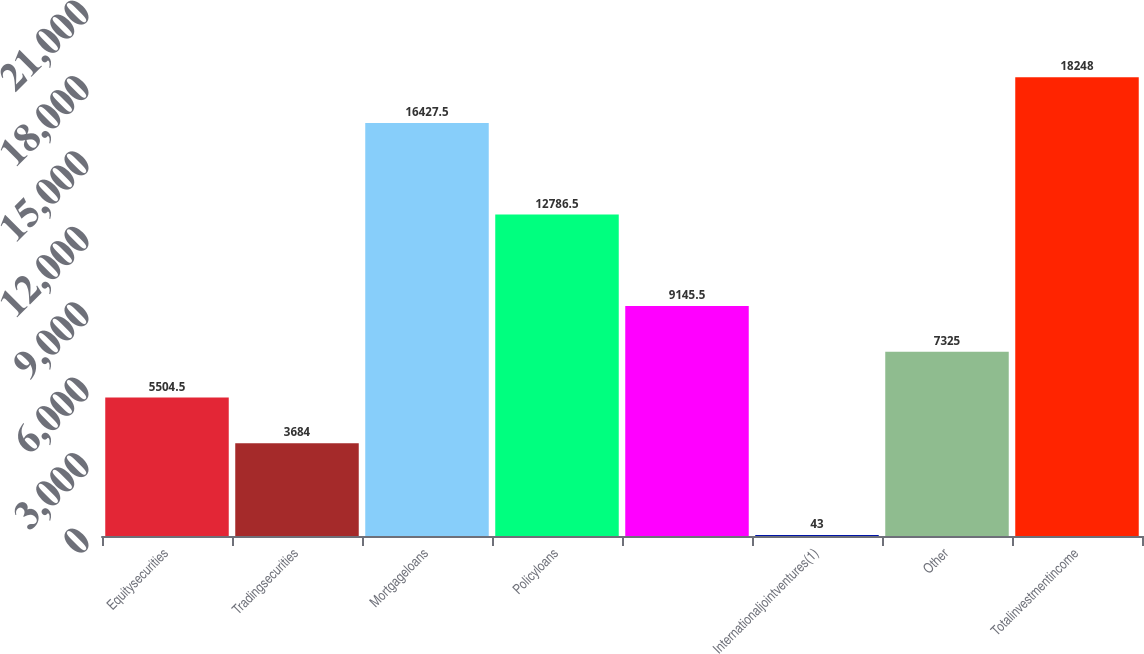Convert chart to OTSL. <chart><loc_0><loc_0><loc_500><loc_500><bar_chart><fcel>Equitysecurities<fcel>Tradingsecurities<fcel>Mortgageloans<fcel>Policyloans<fcel>Unnamed: 4<fcel>Internationaljointventures(1)<fcel>Other<fcel>Totalinvestmentincome<nl><fcel>5504.5<fcel>3684<fcel>16427.5<fcel>12786.5<fcel>9145.5<fcel>43<fcel>7325<fcel>18248<nl></chart> 